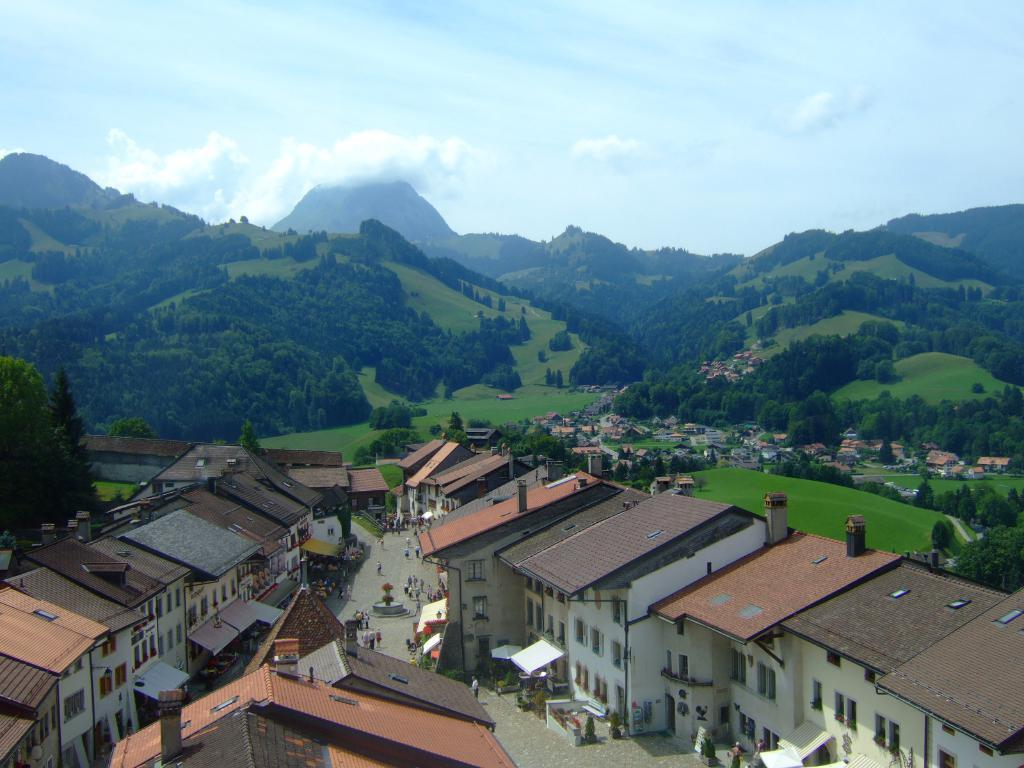What type of structures can be seen in the image? There are houses in the image. What can be seen on the ground in the image? The ground is visible in the image, and there are objects on it. Can you describe the people in the image? There are people in the image, but their specific actions or characteristics are not mentioned in the facts. What type of vegetation is present in the image? There is grass and trees in the image. What type of terrain can be seen in the image? There are hills in the image. What is visible in the sky in the image? The sky is visible in the image, and there are clouds in it. What letters are being passed around by the team in the image? There is no mention of a team or letters in the image; it features houses, people, and natural elements like grass, trees, hills, and clouds. 